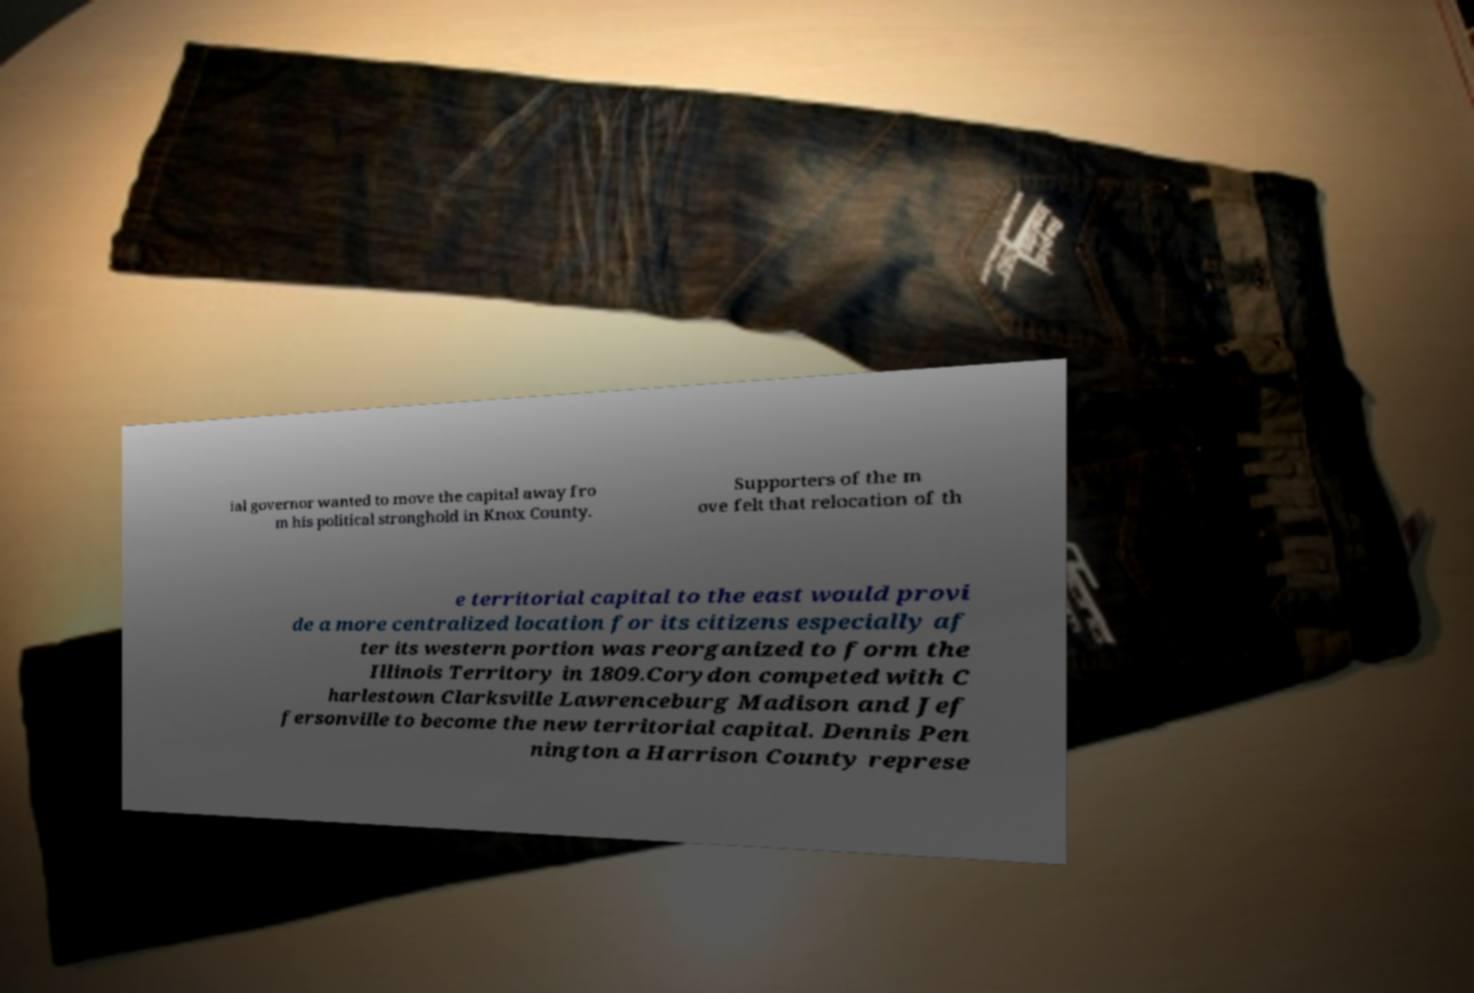Can you accurately transcribe the text from the provided image for me? ial governor wanted to move the capital away fro m his political stronghold in Knox County. Supporters of the m ove felt that relocation of th e territorial capital to the east would provi de a more centralized location for its citizens especially af ter its western portion was reorganized to form the Illinois Territory in 1809.Corydon competed with C harlestown Clarksville Lawrenceburg Madison and Jef fersonville to become the new territorial capital. Dennis Pen nington a Harrison County represe 